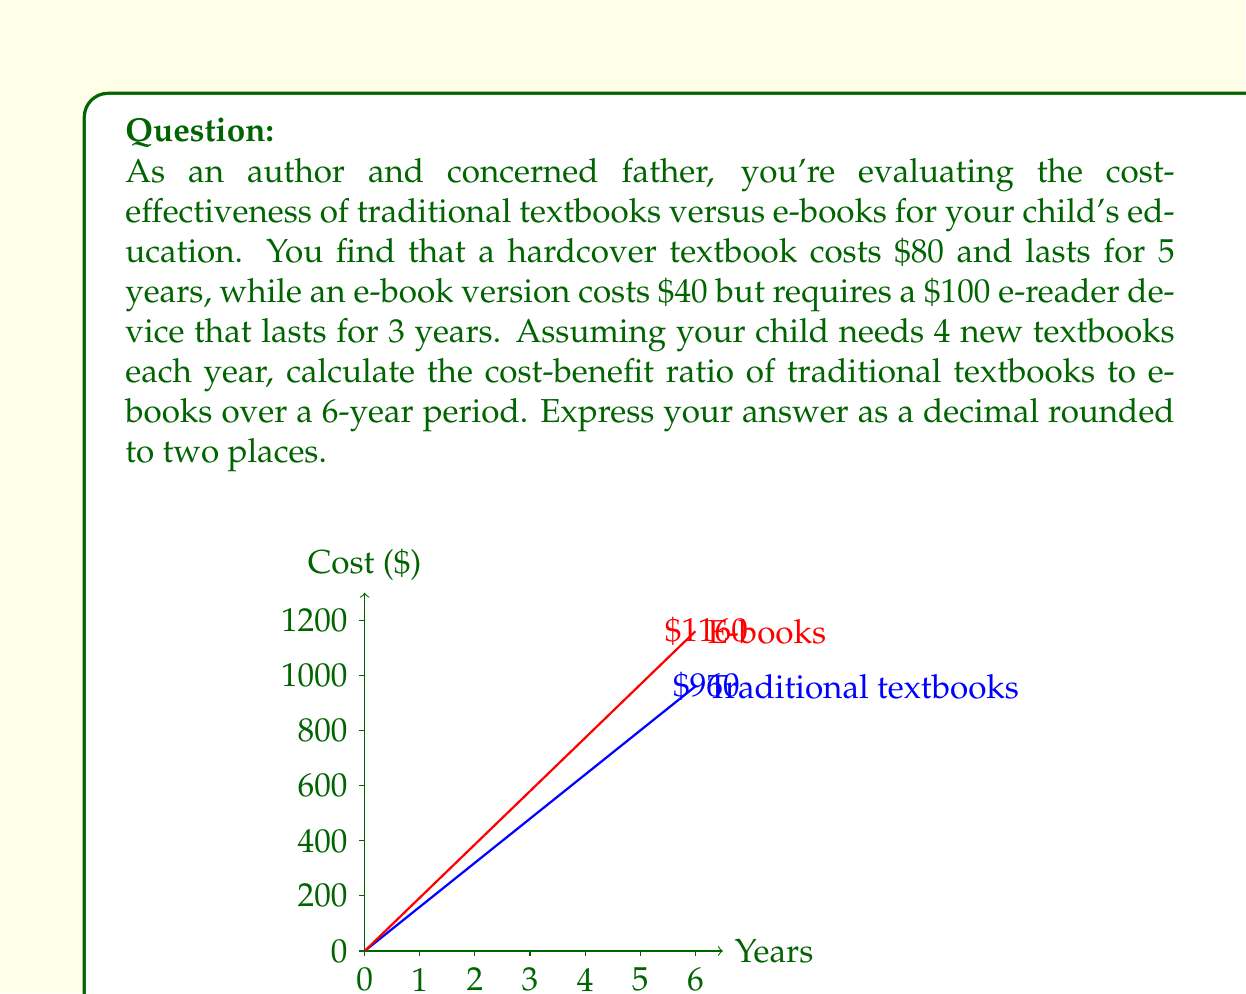Show me your answer to this math problem. Let's break this down step-by-step:

1) First, calculate the cost of traditional textbooks over 6 years:
   - Cost per year = 4 books × $80 = $320
   - Total cost for 6 years = $320 × 6 = $1920

2) Now, calculate the cost of e-books over 6 years:
   - E-book cost per year = 4 books × $40 = $160
   - E-reader cost over 6 years = $100 × 2 (need to replace once) = $200
   - Total e-book cost for 6 years = ($160 × 6) + $200 = $1160

3) The cost-benefit ratio is defined as:
   $$ \text{Cost-Benefit Ratio} = \frac{\text{Cost of Traditional Textbooks}}{\text{Cost of E-books}} $$

4) Plugging in our values:
   $$ \text{Cost-Benefit Ratio} = \frac{1920}{1160} \approx 1.66 $$

5) Rounding to two decimal places: 1.66

This ratio indicates that traditional textbooks are about 1.66 times more expensive than e-books over the 6-year period.
Answer: 1.66 